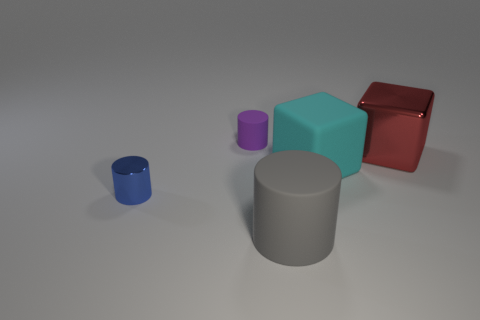Is the number of big rubber cylinders that are behind the small blue cylinder greater than the number of purple matte objects behind the big gray cylinder?
Your response must be concise. No. Is there anything else that is the same color as the matte cube?
Ensure brevity in your answer.  No. Is there a matte cylinder in front of the tiny cylinder that is to the right of the metallic thing that is to the left of the big cylinder?
Offer a terse response. Yes. There is a tiny thing behind the big shiny block; is its shape the same as the gray object?
Your response must be concise. Yes. Is the number of tiny blue cylinders on the right side of the large shiny object less than the number of big red cubes that are on the right side of the purple cylinder?
Your response must be concise. Yes. What is the big red thing made of?
Ensure brevity in your answer.  Metal. What number of cylinders are to the right of the tiny purple matte thing?
Ensure brevity in your answer.  1. Is the number of large cyan rubber cubes left of the tiny purple matte cylinder less than the number of brown metallic balls?
Your response must be concise. No. The metal block is what color?
Provide a succinct answer. Red. The other big matte object that is the same shape as the large red thing is what color?
Provide a succinct answer. Cyan. 